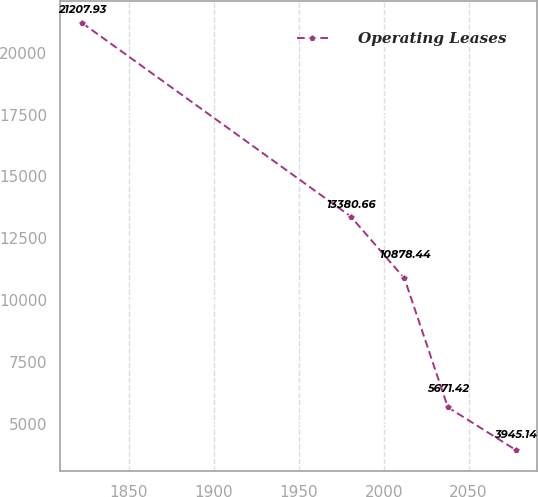Convert chart to OTSL. <chart><loc_0><loc_0><loc_500><loc_500><line_chart><ecel><fcel>Operating Leases<nl><fcel>1822.28<fcel>21207.9<nl><fcel>1980.6<fcel>13380.7<nl><fcel>2012.25<fcel>10878.4<nl><fcel>2037.81<fcel>5671.42<nl><fcel>2077.83<fcel>3945.14<nl></chart> 